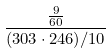Convert formula to latex. <formula><loc_0><loc_0><loc_500><loc_500>\frac { \frac { 9 } { 6 0 } } { ( 3 0 3 \cdot 2 4 6 ) / 1 0 }</formula> 